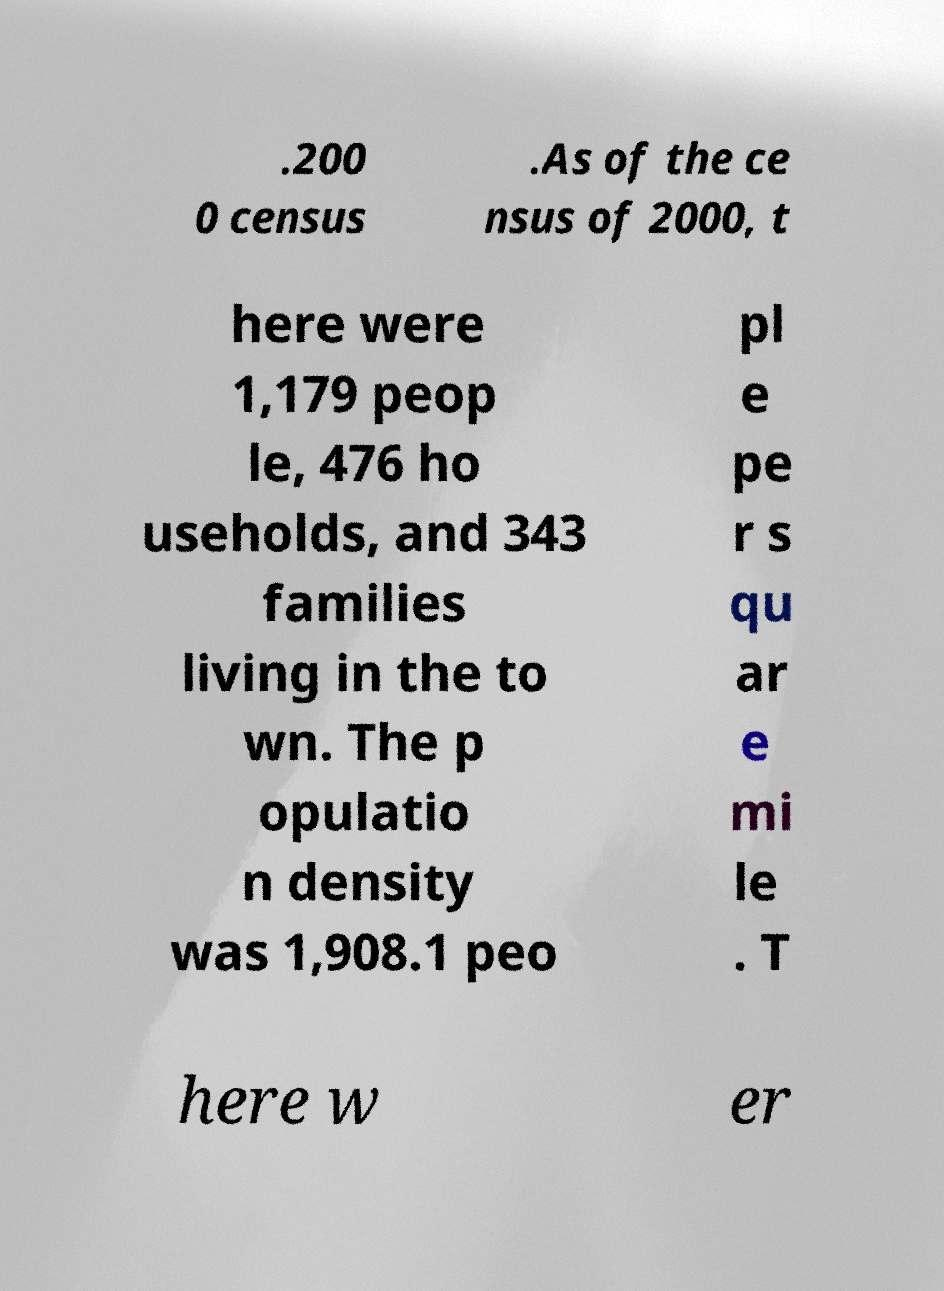I need the written content from this picture converted into text. Can you do that? .200 0 census .As of the ce nsus of 2000, t here were 1,179 peop le, 476 ho useholds, and 343 families living in the to wn. The p opulatio n density was 1,908.1 peo pl e pe r s qu ar e mi le . T here w er 